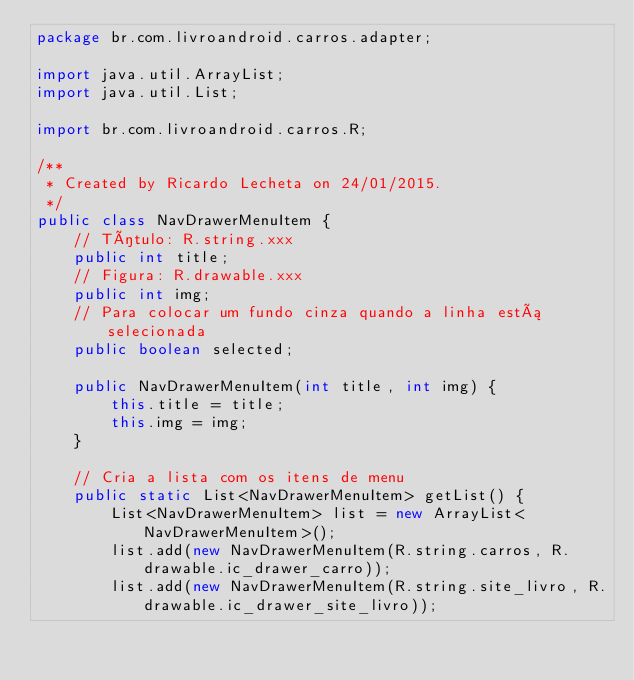<code> <loc_0><loc_0><loc_500><loc_500><_Java_>package br.com.livroandroid.carros.adapter;

import java.util.ArrayList;
import java.util.List;

import br.com.livroandroid.carros.R;

/**
 * Created by Ricardo Lecheta on 24/01/2015.
 */
public class NavDrawerMenuItem {
    // Título: R.string.xxx
    public int title;
    // Figura: R.drawable.xxx
    public int img;
    // Para colocar um fundo cinza quando a linha está selecionada
    public boolean selected;

    public NavDrawerMenuItem(int title, int img) {
        this.title = title;
        this.img = img;
    }

    // Cria a lista com os itens de menu
    public static List<NavDrawerMenuItem> getList() {
        List<NavDrawerMenuItem> list = new ArrayList<NavDrawerMenuItem>();
        list.add(new NavDrawerMenuItem(R.string.carros, R.drawable.ic_drawer_carro));
        list.add(new NavDrawerMenuItem(R.string.site_livro, R.drawable.ic_drawer_site_livro));</code> 